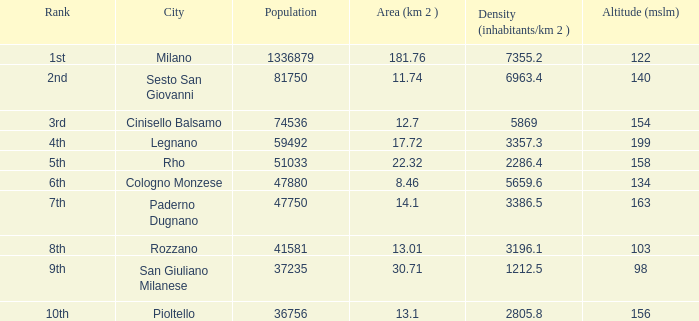01, a population None. 